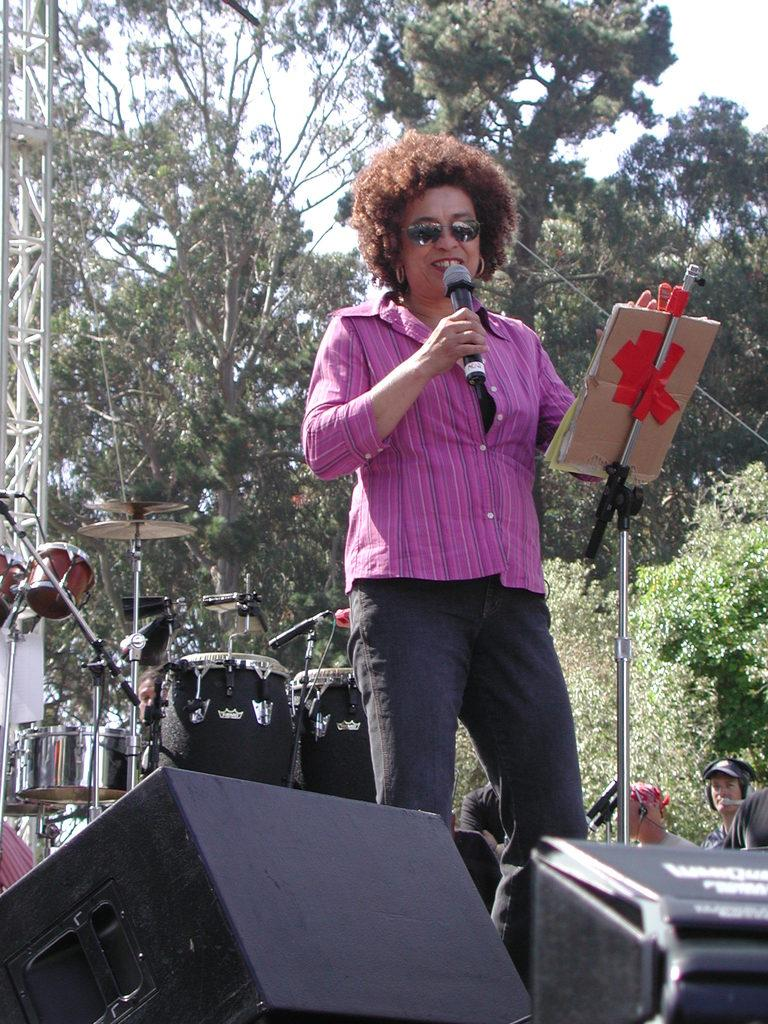Who is the main subject in the image? There is a woman in the image. What is the woman wearing? The woman is wearing a pink shirt. What is the woman holding in the image? The woman is holding a microphone. Where is the woman located in the image? The woman is standing on a stage. What can be seen in the background of the image? There are electronic drums, trees, and people in the background of the image. What type of powder is being used to create the texture of the woman's shirt in the image? There is no powder or texture mentioned in the image; the woman is simply wearing a pink shirt. 